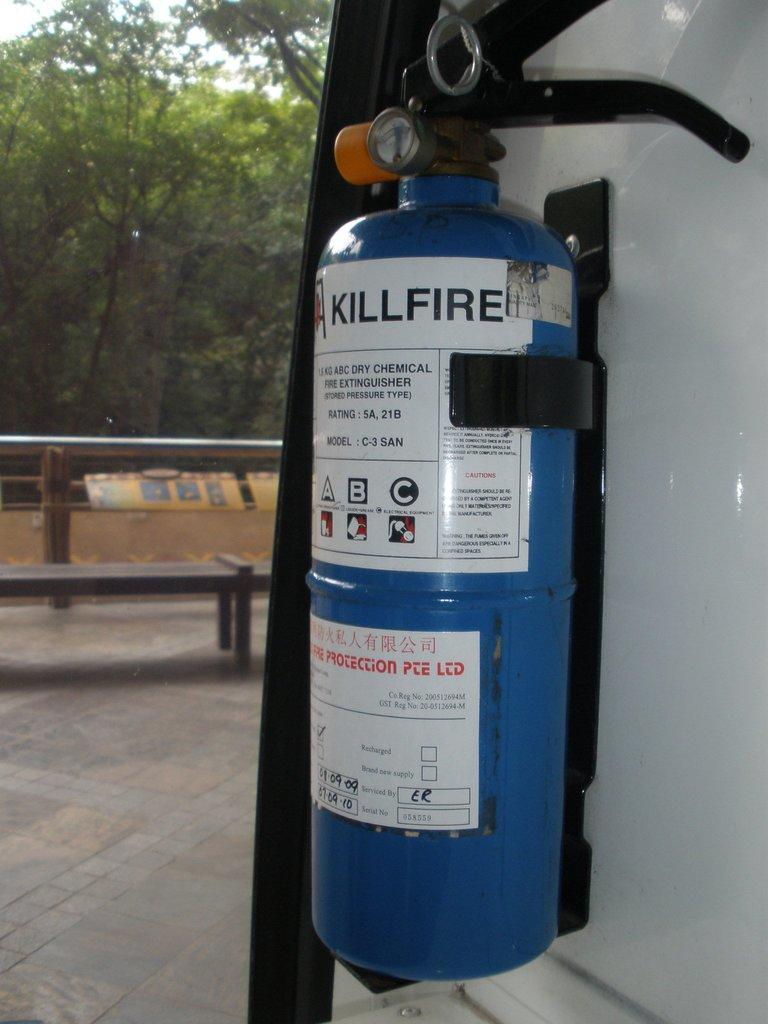What safety device is present in the image? There is a fire extinguisher in the image. Where is the fire extinguisher located? The fire extinguisher is hanged on a wall. What type of seating is visible in the image? There is a bench visible in the image. What type of barrier can be seen in the image? There is a fence in the image. What type of vegetation is present in the image? There are trees in the image. What type of cork is used to seal the fence in the image? There is no cork present in the image, nor is there any indication that the fence needs to be sealed. 